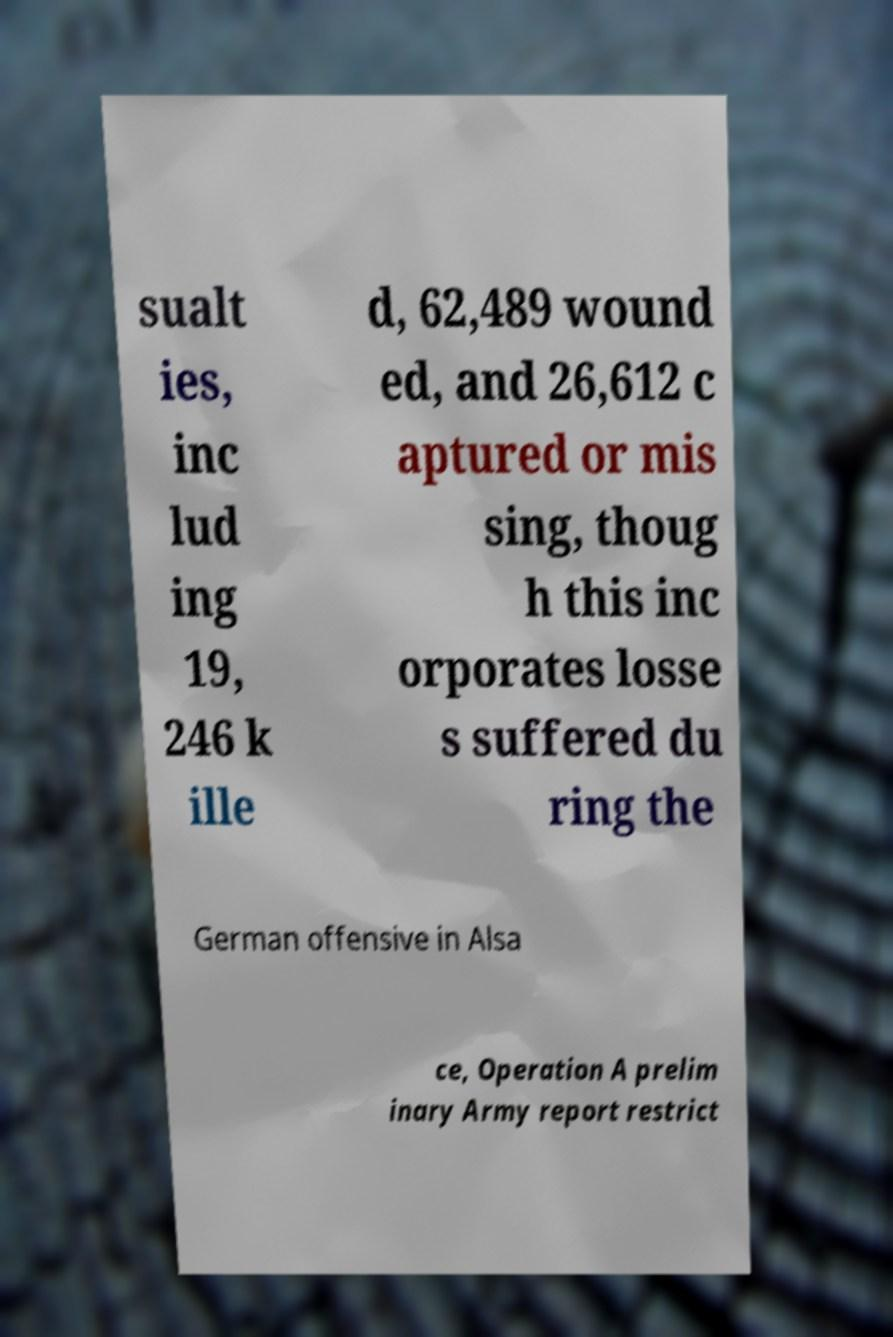There's text embedded in this image that I need extracted. Can you transcribe it verbatim? sualt ies, inc lud ing 19, 246 k ille d, 62,489 wound ed, and 26,612 c aptured or mis sing, thoug h this inc orporates losse s suffered du ring the German offensive in Alsa ce, Operation A prelim inary Army report restrict 